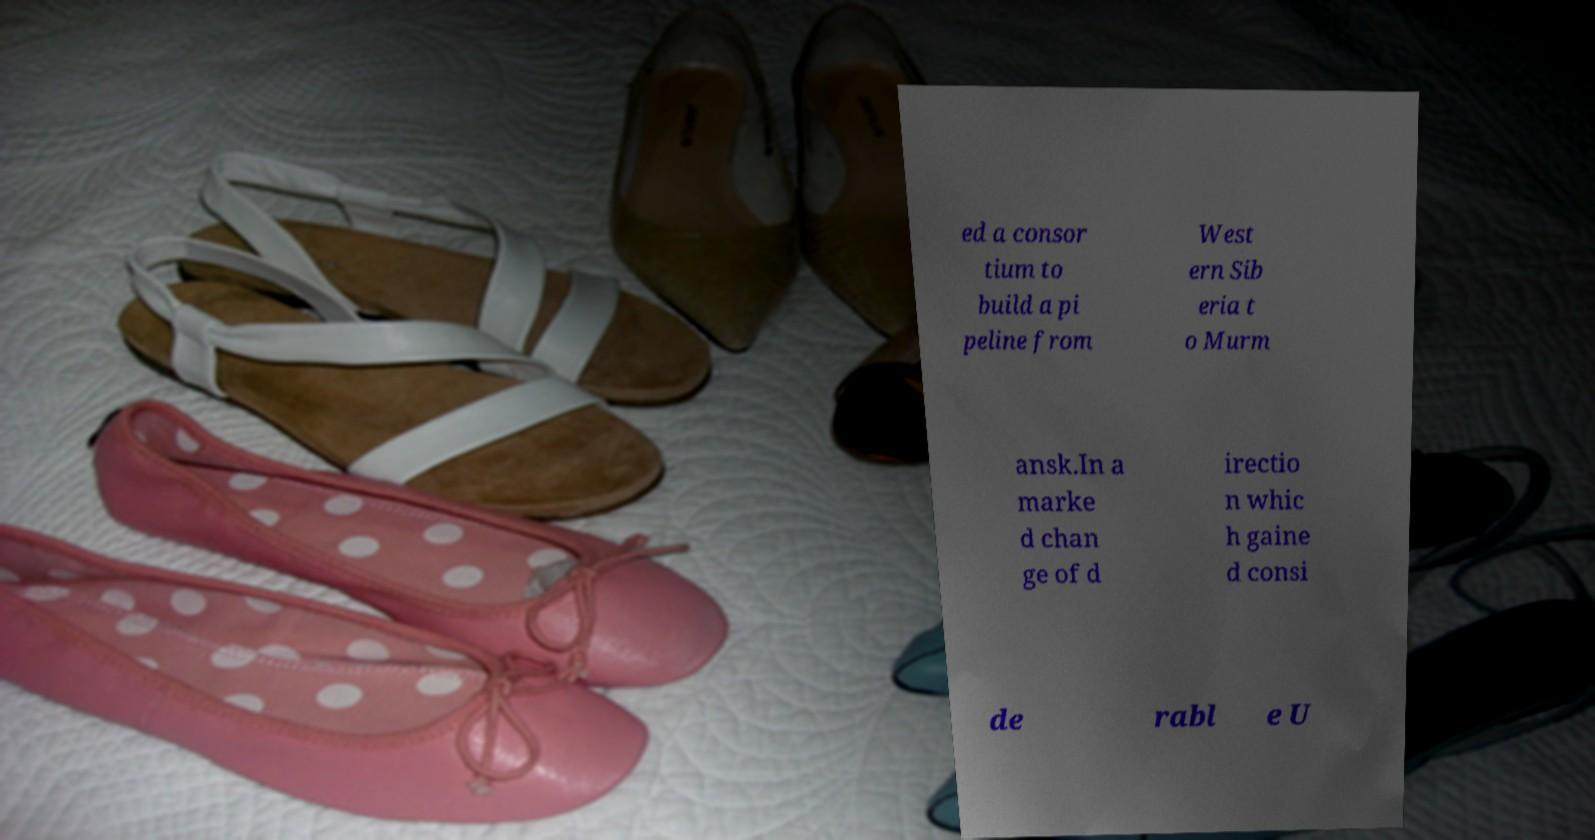I need the written content from this picture converted into text. Can you do that? ed a consor tium to build a pi peline from West ern Sib eria t o Murm ansk.In a marke d chan ge of d irectio n whic h gaine d consi de rabl e U 